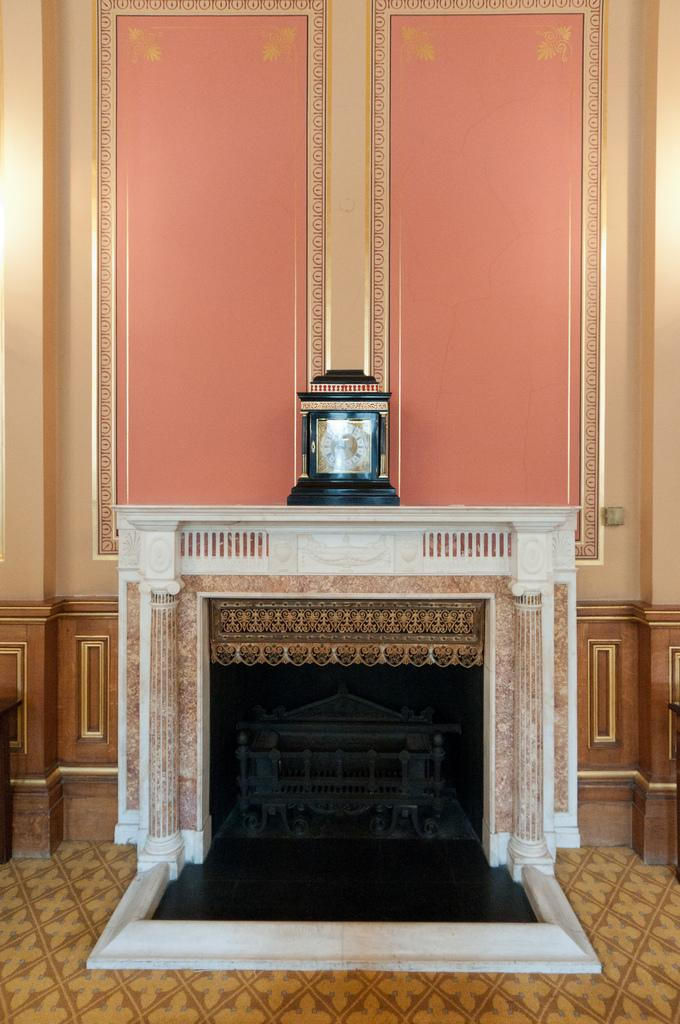What is the main feature of the image? There is a fireplace in the image. What is located above the fireplace? There is a wall clock at the top of the fireplace. How close is the wall clock to the wall? The wall clock is near the wall. What is placed inside the fireplace? There is a model of a building in the fireplace. What type of food is being prepared on the appliance in the image? There is no appliance or food preparation visible in the image. 